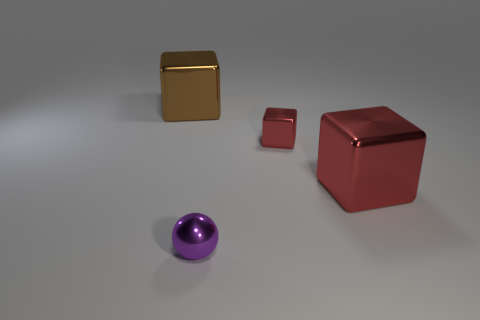Subtract all green cylinders. How many red cubes are left? 2 Subtract all big metal cubes. How many cubes are left? 1 Add 3 tiny rubber cylinders. How many objects exist? 7 Subtract all cyan cubes. Subtract all cyan spheres. How many cubes are left? 3 Subtract all blocks. How many objects are left? 1 Add 2 large metallic objects. How many large metallic objects exist? 4 Subtract 0 green cylinders. How many objects are left? 4 Subtract all tiny shiny things. Subtract all big metal objects. How many objects are left? 0 Add 3 tiny purple shiny spheres. How many tiny purple shiny spheres are left? 4 